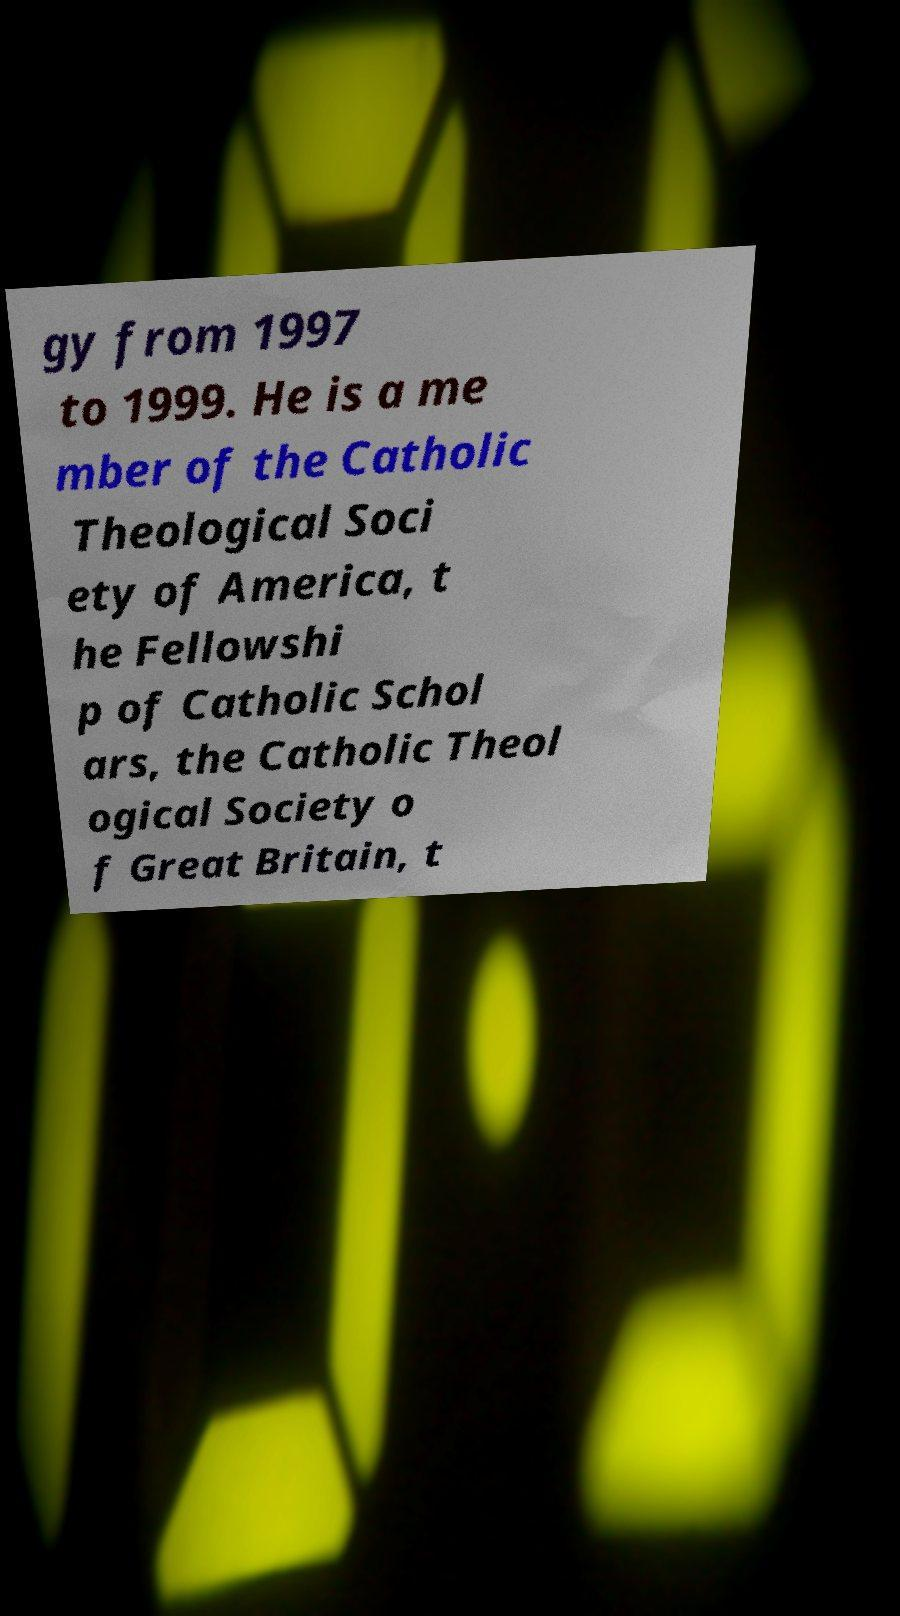Could you extract and type out the text from this image? gy from 1997 to 1999. He is a me mber of the Catholic Theological Soci ety of America, t he Fellowshi p of Catholic Schol ars, the Catholic Theol ogical Society o f Great Britain, t 